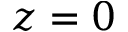<formula> <loc_0><loc_0><loc_500><loc_500>z = 0</formula> 